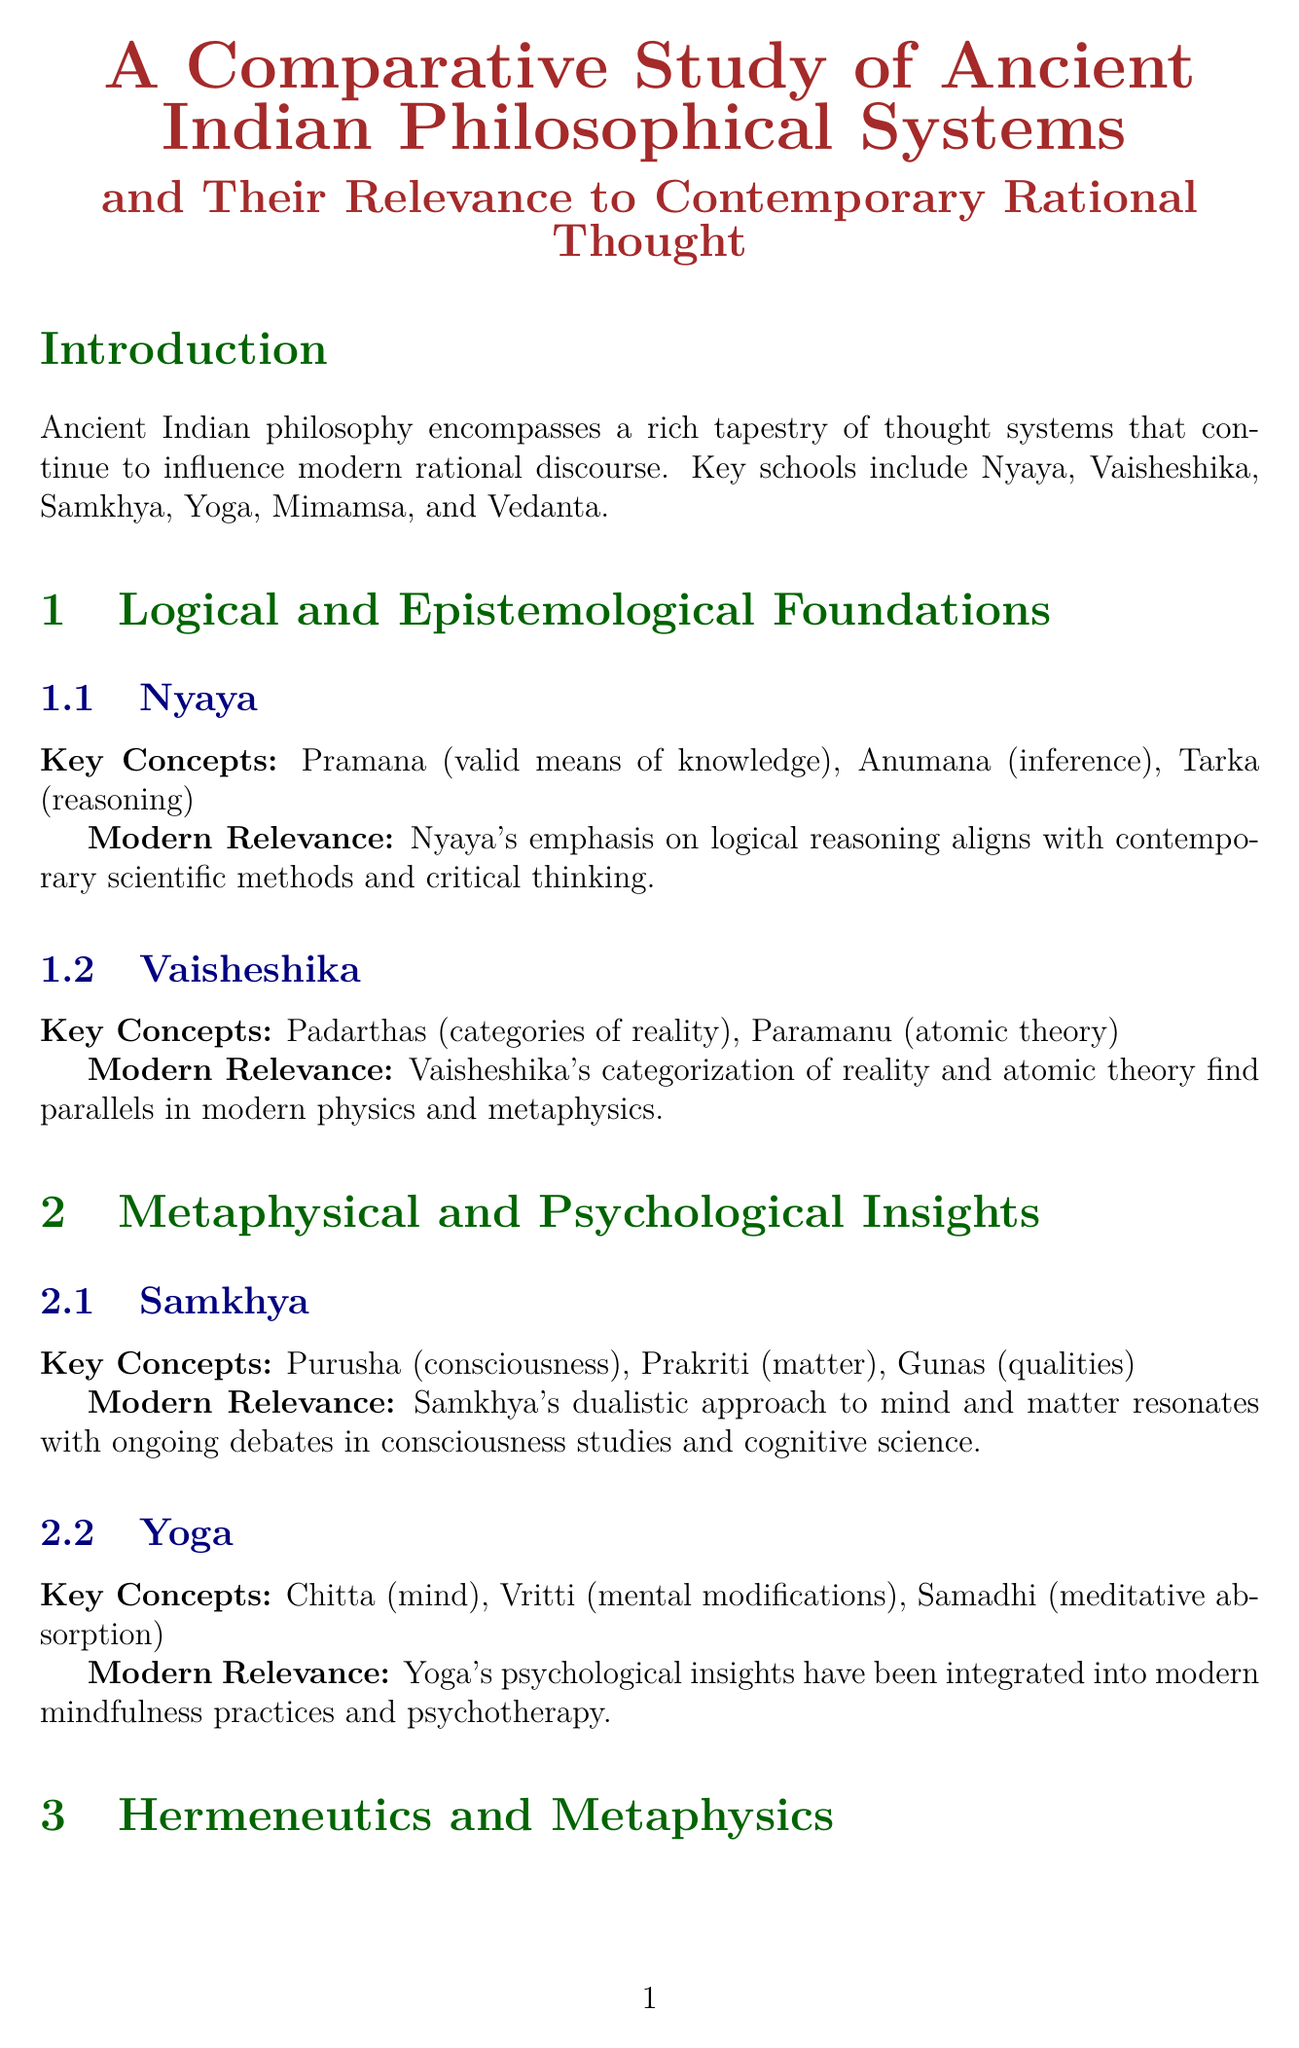What are the key schools of ancient Indian philosophy? The key schools mentioned in the document include Nyaya, Vaisheshika, Samkhya, Yoga, Mimamsa, and Vedanta.
Answer: Nyaya, Vaisheshika, Samkhya, Yoga, Mimamsa, Vedanta Who contributed to the application of Indian philosophical concepts to modern economics? The document states Amartya Sen contributed to applying Indian philosophical concepts to modern economics and social choice theory.
Answer: Amartya Sen What concept in Vaisheshika has parallels in modern physics? The concept related to atomic theory in Vaisheshika is highlighted in the document as finding parallels in modern physics.
Answer: Paramanu Which Indian philosophical system is known for its hermeneutical principles? The document identifies Mimamsa as the philosophical system known for its hermeneutical principles.
Answer: Mimamsa What is the modern relevance of Samkhya? The document indicates that Samkhya's dualistic approach to mind and matter resonates with ongoing debates in consciousness studies and cognitive science.
Answer: Ongoing debates in consciousness studies In which field do Indian theories of mind and consciousness provide frameworks? The document mentions that ancient Indian theories of mind and consciousness provide alternative frameworks in the field of cognitive science.
Answer: Cognitive Science Which term relates to the interconnectedness presented in Indian philosophy? The term described in the document in relation to interconnectedness in Indian philosophy is not specified, but it discusses concepts aligning with modern ecological perspectives.
Answer: Interconnectedness What is the future direction mentioned for integrating Indian philosophical concepts? The document suggests further integration of Indian philosophical concepts into modern academic discourse as a future direction.
Answer: Further integration What is the primary focus of the conclusion in the document? The conclusion focuses on the value of ancient Indian philosophical systems in enriching contemporary rational thought across various disciplines.
Answer: Enriching contemporary rational thought 